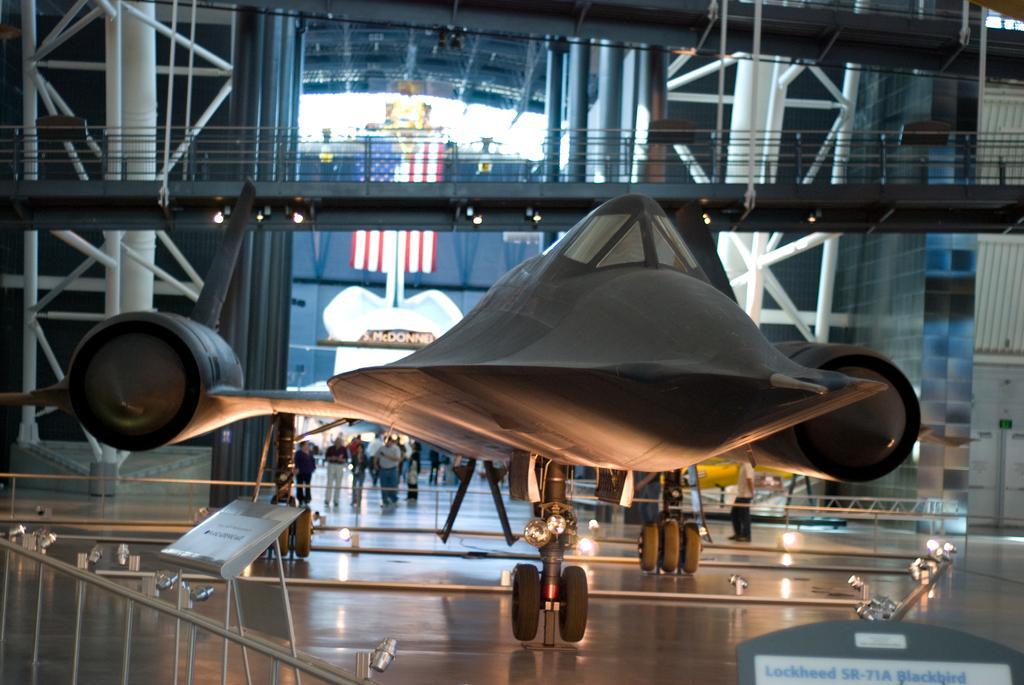In one or two sentences, can you explain what this image depicts? In this image I can see an aircraft on the floor. To the left I can see the board and the railing. In the back there are few people with different color dresses. It is inside the building. 